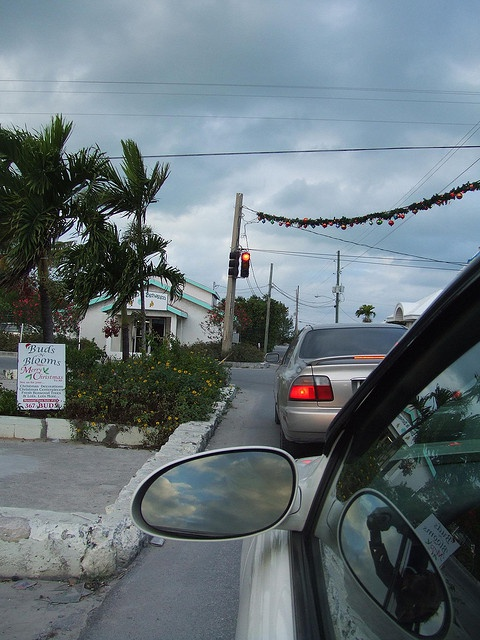Describe the objects in this image and their specific colors. I can see car in gray, black, purple, and darkgray tones, car in gray, black, darkgray, and darkblue tones, car in gray, darkgray, and black tones, traffic light in gray, black, lightgray, darkgray, and maroon tones, and traffic light in gray, black, and darkgray tones in this image. 